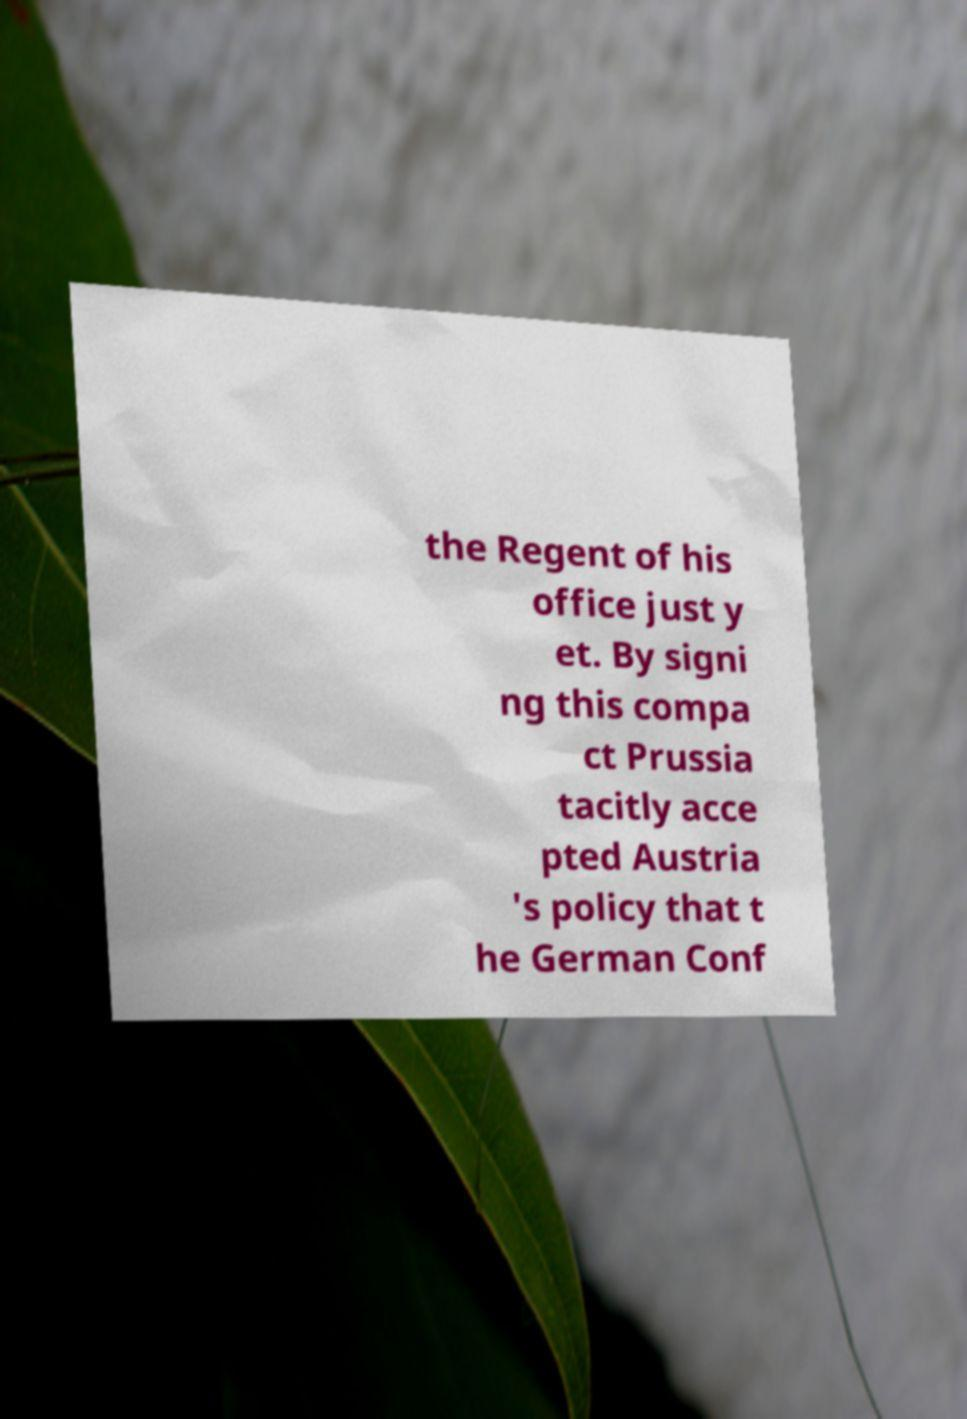There's text embedded in this image that I need extracted. Can you transcribe it verbatim? the Regent of his office just y et. By signi ng this compa ct Prussia tacitly acce pted Austria 's policy that t he German Conf 